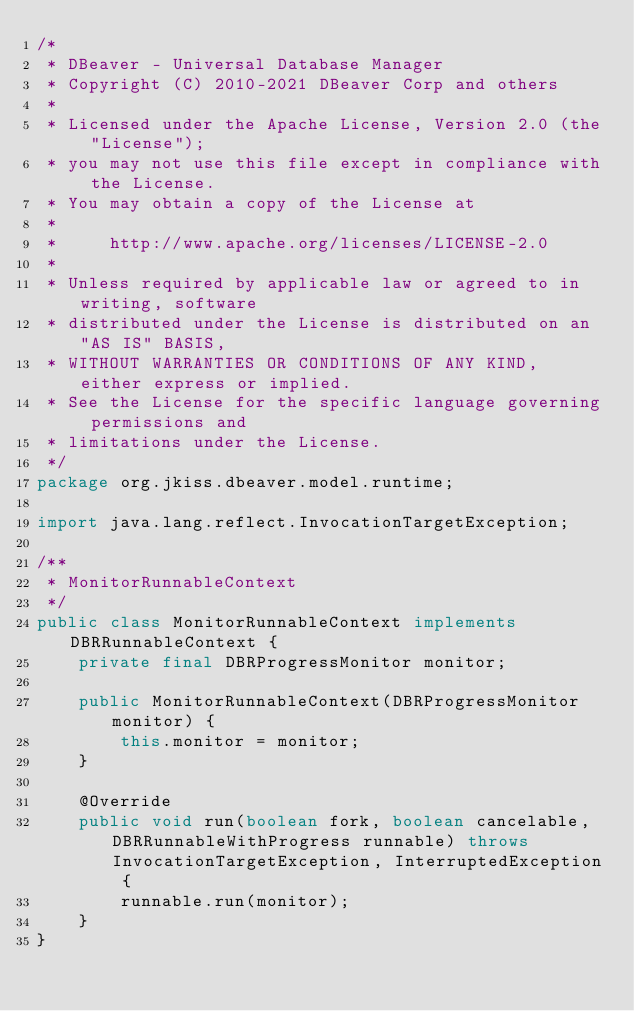Convert code to text. <code><loc_0><loc_0><loc_500><loc_500><_Java_>/*
 * DBeaver - Universal Database Manager
 * Copyright (C) 2010-2021 DBeaver Corp and others
 *
 * Licensed under the Apache License, Version 2.0 (the "License");
 * you may not use this file except in compliance with the License.
 * You may obtain a copy of the License at
 *
 *     http://www.apache.org/licenses/LICENSE-2.0
 *
 * Unless required by applicable law or agreed to in writing, software
 * distributed under the License is distributed on an "AS IS" BASIS,
 * WITHOUT WARRANTIES OR CONDITIONS OF ANY KIND, either express or implied.
 * See the License for the specific language governing permissions and
 * limitations under the License.
 */
package org.jkiss.dbeaver.model.runtime;

import java.lang.reflect.InvocationTargetException;

/**
 * MonitorRunnableContext
 */
public class MonitorRunnableContext implements DBRRunnableContext {
    private final DBRProgressMonitor monitor;

    public MonitorRunnableContext(DBRProgressMonitor monitor) {
        this.monitor = monitor;
    }

    @Override
    public void run(boolean fork, boolean cancelable, DBRRunnableWithProgress runnable) throws InvocationTargetException, InterruptedException {
        runnable.run(monitor);
    }
}
</code> 